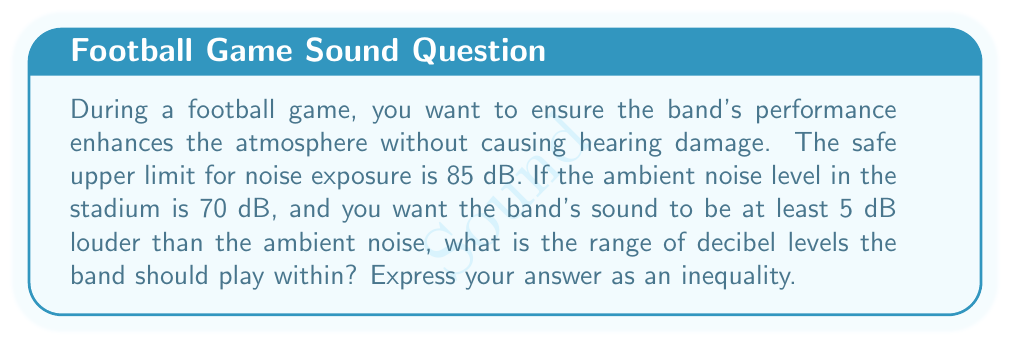Help me with this question. Let's approach this step-by-step:

1) First, we need to establish the lower bound of the band's sound level:
   - The ambient noise level is 70 dB
   - The band should be at least 5 dB louder
   - So, the lower bound is: $70 + 5 = 75$ dB

2) Now, let's consider the upper bound:
   - The safe upper limit for noise exposure is 85 dB
   - This becomes our upper bound

3) Let $x$ represent the band's sound level in decibels

4) We can now express this as an inequality:
   $75 \leq x \leq 85$

5) This inequality represents the range of decibel levels the band should play within:
   - At least 75 dB to be heard clearly above the ambient noise
   - No more than 85 dB to avoid potential hearing damage
Answer: $75 \leq x \leq 85$, where $x$ is the band's sound level in dB 